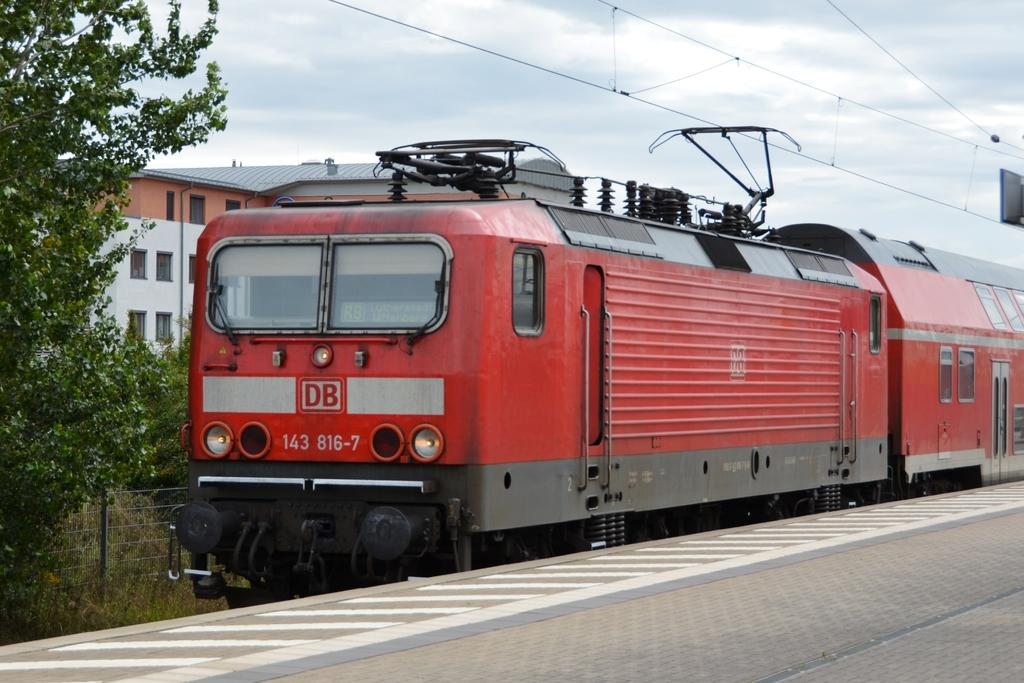<image>
Relay a brief, clear account of the picture shown. Train number 143 816-7 has the letters DB on the front of the engine. 